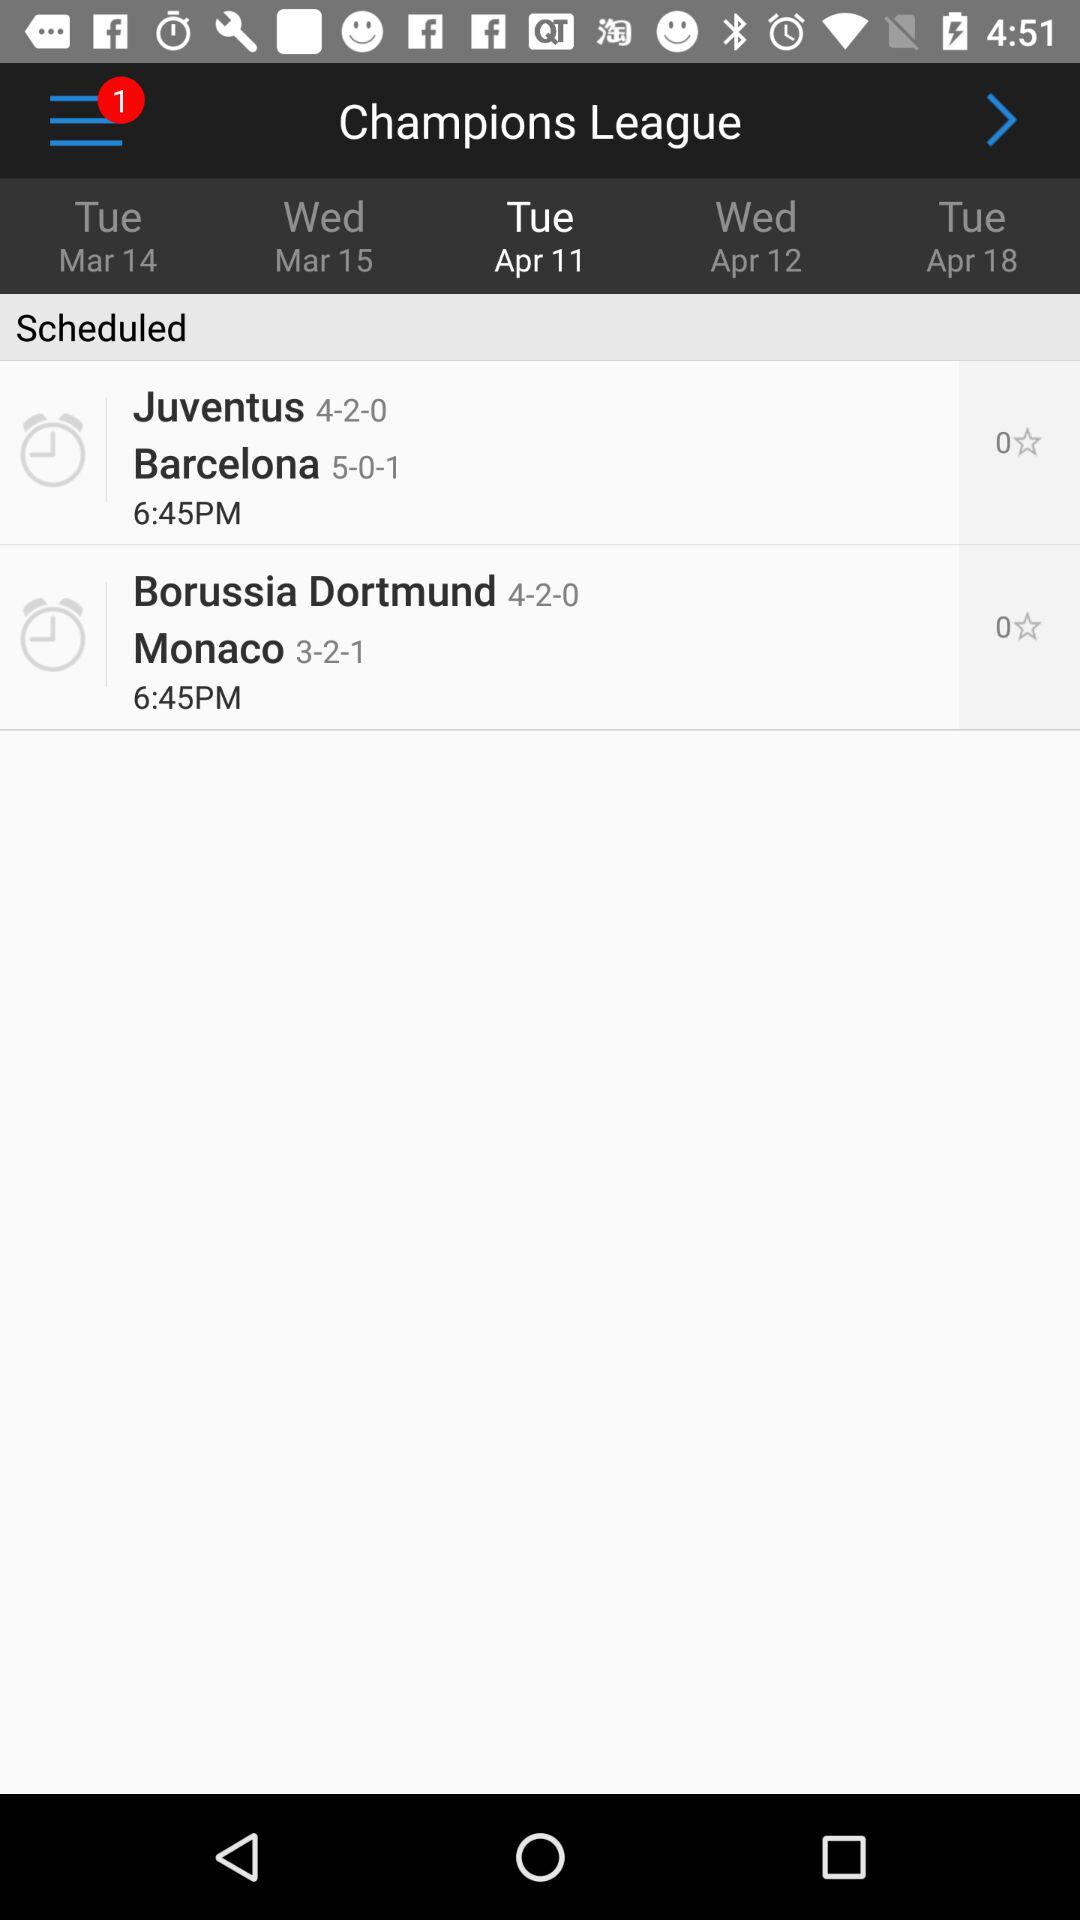How many notifications are there? There is 1 notification. 